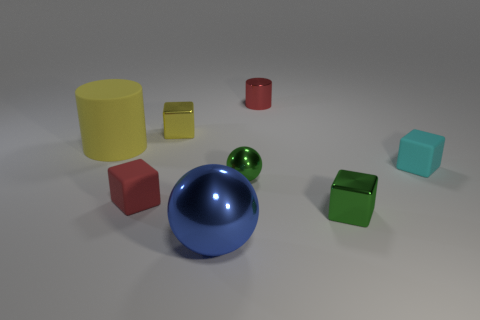Subtract all cyan rubber cubes. How many cubes are left? 3 Add 7 tiny red metallic objects. How many tiny red metallic objects exist? 8 Add 2 yellow things. How many objects exist? 10 Subtract all cyan cubes. How many cubes are left? 3 Subtract 0 brown balls. How many objects are left? 8 Subtract all cylinders. How many objects are left? 6 Subtract 3 blocks. How many blocks are left? 1 Subtract all brown cylinders. Subtract all red spheres. How many cylinders are left? 2 Subtract all purple spheres. How many brown cylinders are left? 0 Subtract all cyan rubber blocks. Subtract all tiny things. How many objects are left? 1 